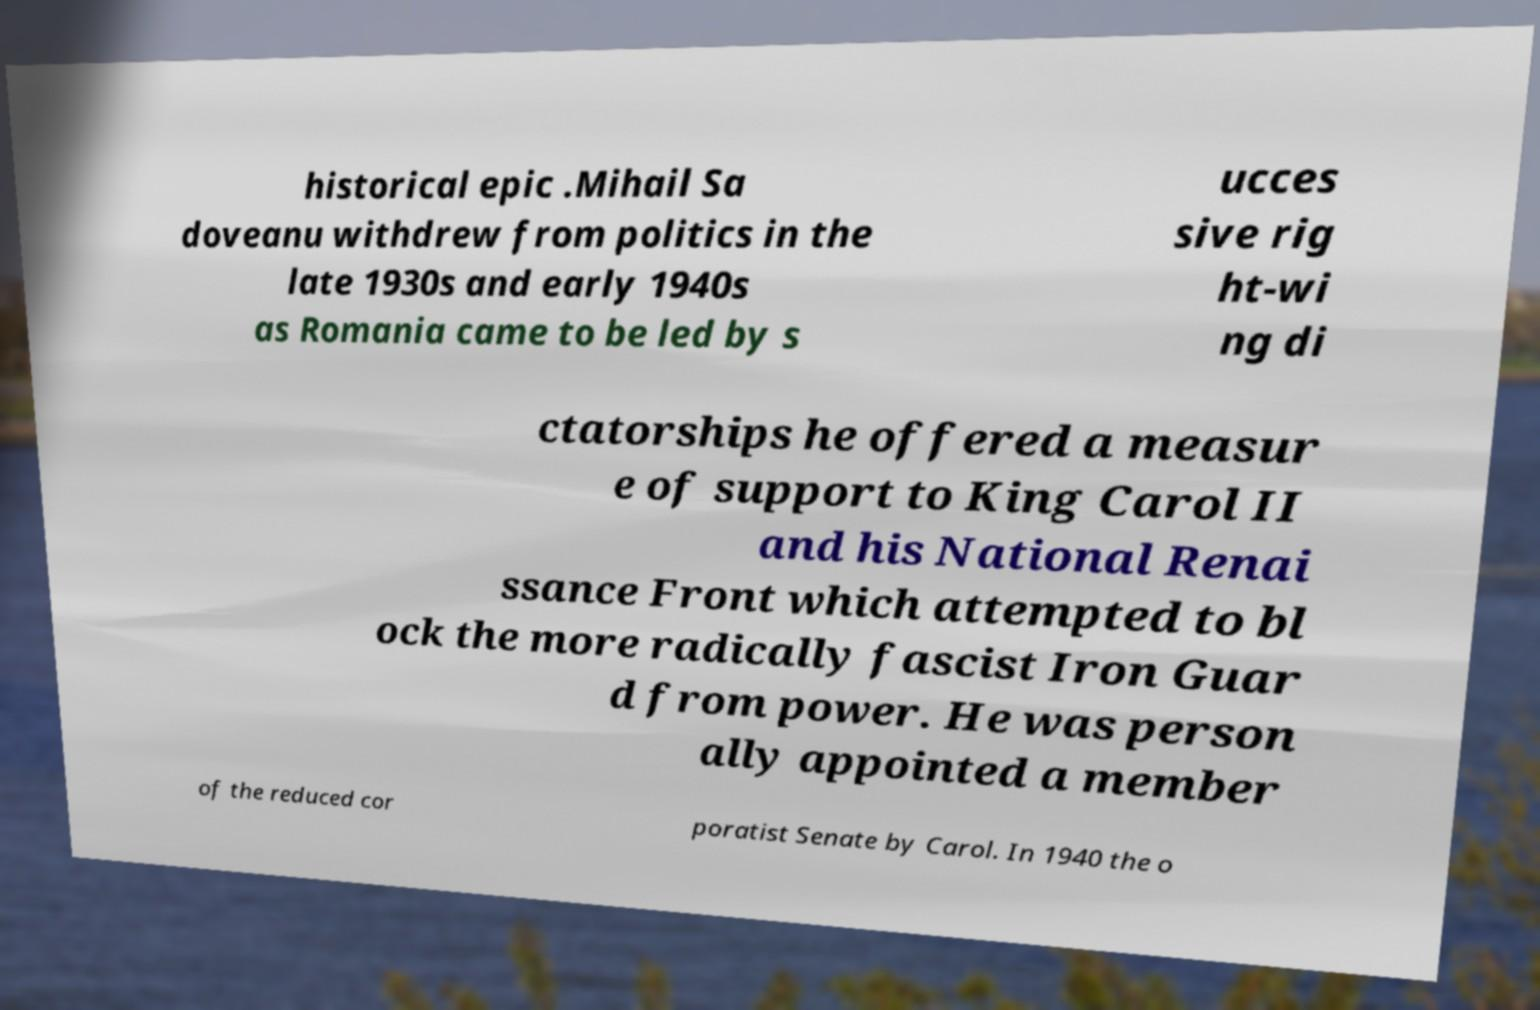Could you extract and type out the text from this image? historical epic .Mihail Sa doveanu withdrew from politics in the late 1930s and early 1940s as Romania came to be led by s ucces sive rig ht-wi ng di ctatorships he offered a measur e of support to King Carol II and his National Renai ssance Front which attempted to bl ock the more radically fascist Iron Guar d from power. He was person ally appointed a member of the reduced cor poratist Senate by Carol. In 1940 the o 